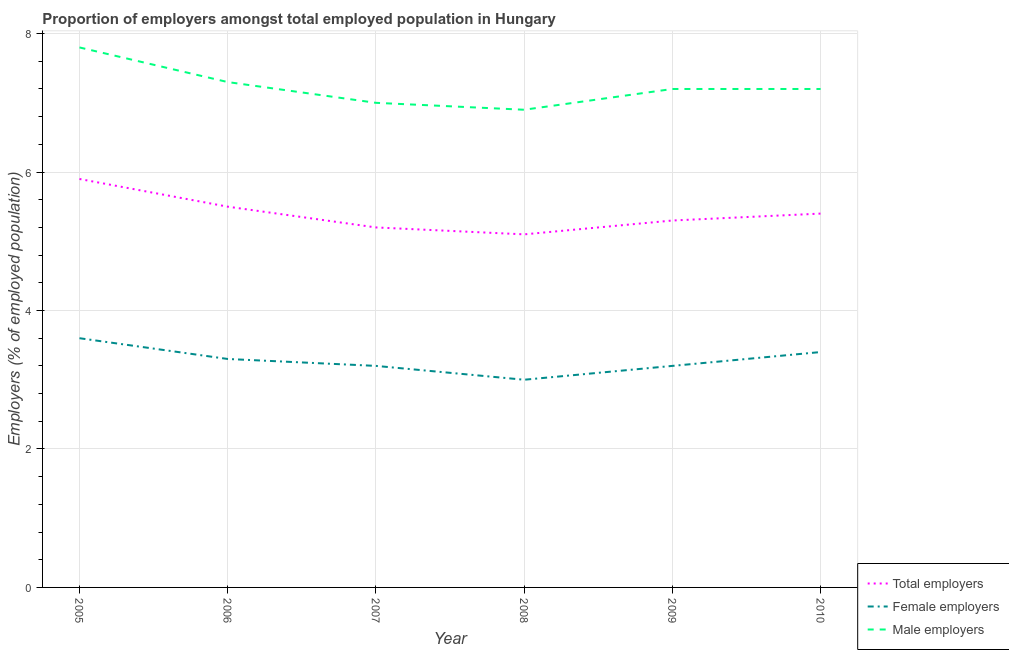Does the line corresponding to percentage of female employers intersect with the line corresponding to percentage of total employers?
Provide a short and direct response. No. What is the percentage of male employers in 2010?
Offer a very short reply. 7.2. Across all years, what is the maximum percentage of total employers?
Give a very brief answer. 5.9. In which year was the percentage of total employers maximum?
Provide a succinct answer. 2005. What is the total percentage of female employers in the graph?
Provide a succinct answer. 19.7. What is the difference between the percentage of female employers in 2006 and that in 2009?
Give a very brief answer. 0.1. What is the difference between the percentage of male employers in 2008 and the percentage of female employers in 2006?
Give a very brief answer. 3.6. What is the average percentage of female employers per year?
Provide a short and direct response. 3.28. In the year 2007, what is the difference between the percentage of male employers and percentage of total employers?
Your answer should be compact. 1.8. In how many years, is the percentage of female employers greater than 3.2 %?
Ensure brevity in your answer.  5. What is the ratio of the percentage of female employers in 2006 to that in 2007?
Your response must be concise. 1.03. Is the percentage of total employers in 2008 less than that in 2010?
Ensure brevity in your answer.  Yes. Is the difference between the percentage of total employers in 2007 and 2008 greater than the difference between the percentage of female employers in 2007 and 2008?
Give a very brief answer. No. What is the difference between the highest and the second highest percentage of total employers?
Make the answer very short. 0.4. What is the difference between the highest and the lowest percentage of total employers?
Ensure brevity in your answer.  0.8. In how many years, is the percentage of total employers greater than the average percentage of total employers taken over all years?
Offer a very short reply. 3. Is it the case that in every year, the sum of the percentage of total employers and percentage of female employers is greater than the percentage of male employers?
Provide a succinct answer. Yes. How many years are there in the graph?
Your response must be concise. 6. Are the values on the major ticks of Y-axis written in scientific E-notation?
Provide a succinct answer. No. How many legend labels are there?
Offer a terse response. 3. How are the legend labels stacked?
Your answer should be very brief. Vertical. What is the title of the graph?
Your answer should be very brief. Proportion of employers amongst total employed population in Hungary. Does "Liquid fuel" appear as one of the legend labels in the graph?
Make the answer very short. No. What is the label or title of the X-axis?
Your answer should be compact. Year. What is the label or title of the Y-axis?
Your response must be concise. Employers (% of employed population). What is the Employers (% of employed population) in Total employers in 2005?
Offer a terse response. 5.9. What is the Employers (% of employed population) of Female employers in 2005?
Provide a short and direct response. 3.6. What is the Employers (% of employed population) of Male employers in 2005?
Provide a short and direct response. 7.8. What is the Employers (% of employed population) in Total employers in 2006?
Offer a terse response. 5.5. What is the Employers (% of employed population) in Female employers in 2006?
Your answer should be compact. 3.3. What is the Employers (% of employed population) of Male employers in 2006?
Provide a short and direct response. 7.3. What is the Employers (% of employed population) in Total employers in 2007?
Your answer should be compact. 5.2. What is the Employers (% of employed population) in Female employers in 2007?
Give a very brief answer. 3.2. What is the Employers (% of employed population) in Total employers in 2008?
Your answer should be very brief. 5.1. What is the Employers (% of employed population) of Female employers in 2008?
Offer a very short reply. 3. What is the Employers (% of employed population) in Male employers in 2008?
Your answer should be compact. 6.9. What is the Employers (% of employed population) of Total employers in 2009?
Keep it short and to the point. 5.3. What is the Employers (% of employed population) in Female employers in 2009?
Make the answer very short. 3.2. What is the Employers (% of employed population) of Male employers in 2009?
Your response must be concise. 7.2. What is the Employers (% of employed population) in Total employers in 2010?
Offer a terse response. 5.4. What is the Employers (% of employed population) of Female employers in 2010?
Your answer should be compact. 3.4. What is the Employers (% of employed population) of Male employers in 2010?
Give a very brief answer. 7.2. Across all years, what is the maximum Employers (% of employed population) in Total employers?
Your answer should be very brief. 5.9. Across all years, what is the maximum Employers (% of employed population) of Female employers?
Your answer should be very brief. 3.6. Across all years, what is the maximum Employers (% of employed population) in Male employers?
Offer a very short reply. 7.8. Across all years, what is the minimum Employers (% of employed population) of Total employers?
Your answer should be very brief. 5.1. Across all years, what is the minimum Employers (% of employed population) in Female employers?
Provide a short and direct response. 3. Across all years, what is the minimum Employers (% of employed population) of Male employers?
Your answer should be very brief. 6.9. What is the total Employers (% of employed population) of Total employers in the graph?
Offer a very short reply. 32.4. What is the total Employers (% of employed population) in Female employers in the graph?
Your answer should be very brief. 19.7. What is the total Employers (% of employed population) of Male employers in the graph?
Your answer should be very brief. 43.4. What is the difference between the Employers (% of employed population) of Female employers in 2005 and that in 2006?
Ensure brevity in your answer.  0.3. What is the difference between the Employers (% of employed population) of Male employers in 2005 and that in 2006?
Your response must be concise. 0.5. What is the difference between the Employers (% of employed population) of Total employers in 2005 and that in 2007?
Ensure brevity in your answer.  0.7. What is the difference between the Employers (% of employed population) of Male employers in 2005 and that in 2007?
Offer a terse response. 0.8. What is the difference between the Employers (% of employed population) in Female employers in 2005 and that in 2008?
Your answer should be compact. 0.6. What is the difference between the Employers (% of employed population) of Male employers in 2005 and that in 2008?
Make the answer very short. 0.9. What is the difference between the Employers (% of employed population) of Total employers in 2005 and that in 2009?
Your answer should be compact. 0.6. What is the difference between the Employers (% of employed population) in Female employers in 2005 and that in 2009?
Your response must be concise. 0.4. What is the difference between the Employers (% of employed population) in Male employers in 2005 and that in 2009?
Your answer should be compact. 0.6. What is the difference between the Employers (% of employed population) in Total employers in 2005 and that in 2010?
Offer a very short reply. 0.5. What is the difference between the Employers (% of employed population) of Female employers in 2005 and that in 2010?
Make the answer very short. 0.2. What is the difference between the Employers (% of employed population) of Total employers in 2006 and that in 2007?
Provide a succinct answer. 0.3. What is the difference between the Employers (% of employed population) in Male employers in 2006 and that in 2007?
Ensure brevity in your answer.  0.3. What is the difference between the Employers (% of employed population) of Total employers in 2006 and that in 2008?
Ensure brevity in your answer.  0.4. What is the difference between the Employers (% of employed population) of Male employers in 2006 and that in 2008?
Make the answer very short. 0.4. What is the difference between the Employers (% of employed population) of Total employers in 2006 and that in 2009?
Keep it short and to the point. 0.2. What is the difference between the Employers (% of employed population) of Female employers in 2006 and that in 2009?
Your response must be concise. 0.1. What is the difference between the Employers (% of employed population) in Male employers in 2006 and that in 2009?
Provide a short and direct response. 0.1. What is the difference between the Employers (% of employed population) in Total employers in 2006 and that in 2010?
Offer a very short reply. 0.1. What is the difference between the Employers (% of employed population) of Female employers in 2006 and that in 2010?
Ensure brevity in your answer.  -0.1. What is the difference between the Employers (% of employed population) in Male employers in 2006 and that in 2010?
Your response must be concise. 0.1. What is the difference between the Employers (% of employed population) in Total employers in 2007 and that in 2008?
Make the answer very short. 0.1. What is the difference between the Employers (% of employed population) of Male employers in 2007 and that in 2009?
Offer a very short reply. -0.2. What is the difference between the Employers (% of employed population) in Total employers in 2008 and that in 2009?
Provide a succinct answer. -0.2. What is the difference between the Employers (% of employed population) in Total employers in 2008 and that in 2010?
Give a very brief answer. -0.3. What is the difference between the Employers (% of employed population) in Female employers in 2008 and that in 2010?
Ensure brevity in your answer.  -0.4. What is the difference between the Employers (% of employed population) in Female employers in 2009 and that in 2010?
Give a very brief answer. -0.2. What is the difference between the Employers (% of employed population) in Male employers in 2009 and that in 2010?
Offer a very short reply. 0. What is the difference between the Employers (% of employed population) in Female employers in 2005 and the Employers (% of employed population) in Male employers in 2006?
Your response must be concise. -3.7. What is the difference between the Employers (% of employed population) of Total employers in 2005 and the Employers (% of employed population) of Female employers in 2007?
Your answer should be compact. 2.7. What is the difference between the Employers (% of employed population) in Female employers in 2005 and the Employers (% of employed population) in Male employers in 2008?
Offer a very short reply. -3.3. What is the difference between the Employers (% of employed population) of Female employers in 2005 and the Employers (% of employed population) of Male employers in 2009?
Make the answer very short. -3.6. What is the difference between the Employers (% of employed population) in Total employers in 2006 and the Employers (% of employed population) in Male employers in 2007?
Keep it short and to the point. -1.5. What is the difference between the Employers (% of employed population) in Total employers in 2006 and the Employers (% of employed population) in Male employers in 2008?
Provide a short and direct response. -1.4. What is the difference between the Employers (% of employed population) of Female employers in 2006 and the Employers (% of employed population) of Male employers in 2008?
Your answer should be very brief. -3.6. What is the difference between the Employers (% of employed population) of Total employers in 2006 and the Employers (% of employed population) of Female employers in 2009?
Offer a very short reply. 2.3. What is the difference between the Employers (% of employed population) of Total employers in 2006 and the Employers (% of employed population) of Male employers in 2009?
Provide a short and direct response. -1.7. What is the difference between the Employers (% of employed population) of Female employers in 2006 and the Employers (% of employed population) of Male employers in 2009?
Your response must be concise. -3.9. What is the difference between the Employers (% of employed population) of Total employers in 2006 and the Employers (% of employed population) of Female employers in 2010?
Ensure brevity in your answer.  2.1. What is the difference between the Employers (% of employed population) in Total employers in 2007 and the Employers (% of employed population) in Male employers in 2008?
Offer a very short reply. -1.7. What is the difference between the Employers (% of employed population) in Total employers in 2007 and the Employers (% of employed population) in Female employers in 2009?
Provide a short and direct response. 2. What is the difference between the Employers (% of employed population) of Female employers in 2007 and the Employers (% of employed population) of Male employers in 2010?
Give a very brief answer. -4. What is the difference between the Employers (% of employed population) of Total employers in 2008 and the Employers (% of employed population) of Male employers in 2009?
Your answer should be very brief. -2.1. What is the difference between the Employers (% of employed population) in Total employers in 2008 and the Employers (% of employed population) in Female employers in 2010?
Give a very brief answer. 1.7. What is the difference between the Employers (% of employed population) of Total employers in 2009 and the Employers (% of employed population) of Female employers in 2010?
Your answer should be very brief. 1.9. What is the average Employers (% of employed population) of Total employers per year?
Keep it short and to the point. 5.4. What is the average Employers (% of employed population) of Female employers per year?
Offer a terse response. 3.28. What is the average Employers (% of employed population) in Male employers per year?
Your answer should be compact. 7.23. In the year 2005, what is the difference between the Employers (% of employed population) in Total employers and Employers (% of employed population) in Female employers?
Make the answer very short. 2.3. In the year 2005, what is the difference between the Employers (% of employed population) of Total employers and Employers (% of employed population) of Male employers?
Give a very brief answer. -1.9. In the year 2006, what is the difference between the Employers (% of employed population) in Total employers and Employers (% of employed population) in Female employers?
Provide a short and direct response. 2.2. In the year 2006, what is the difference between the Employers (% of employed population) in Total employers and Employers (% of employed population) in Male employers?
Your answer should be very brief. -1.8. In the year 2007, what is the difference between the Employers (% of employed population) of Total employers and Employers (% of employed population) of Female employers?
Make the answer very short. 2. In the year 2007, what is the difference between the Employers (% of employed population) of Female employers and Employers (% of employed population) of Male employers?
Your answer should be compact. -3.8. In the year 2008, what is the difference between the Employers (% of employed population) in Total employers and Employers (% of employed population) in Female employers?
Give a very brief answer. 2.1. In the year 2008, what is the difference between the Employers (% of employed population) of Female employers and Employers (% of employed population) of Male employers?
Your answer should be compact. -3.9. In the year 2010, what is the difference between the Employers (% of employed population) in Total employers and Employers (% of employed population) in Female employers?
Provide a short and direct response. 2. In the year 2010, what is the difference between the Employers (% of employed population) of Total employers and Employers (% of employed population) of Male employers?
Give a very brief answer. -1.8. What is the ratio of the Employers (% of employed population) of Total employers in 2005 to that in 2006?
Your answer should be very brief. 1.07. What is the ratio of the Employers (% of employed population) in Male employers in 2005 to that in 2006?
Your answer should be very brief. 1.07. What is the ratio of the Employers (% of employed population) of Total employers in 2005 to that in 2007?
Your answer should be compact. 1.13. What is the ratio of the Employers (% of employed population) in Male employers in 2005 to that in 2007?
Your response must be concise. 1.11. What is the ratio of the Employers (% of employed population) of Total employers in 2005 to that in 2008?
Your response must be concise. 1.16. What is the ratio of the Employers (% of employed population) in Female employers in 2005 to that in 2008?
Keep it short and to the point. 1.2. What is the ratio of the Employers (% of employed population) in Male employers in 2005 to that in 2008?
Ensure brevity in your answer.  1.13. What is the ratio of the Employers (% of employed population) of Total employers in 2005 to that in 2009?
Keep it short and to the point. 1.11. What is the ratio of the Employers (% of employed population) in Total employers in 2005 to that in 2010?
Offer a terse response. 1.09. What is the ratio of the Employers (% of employed population) in Female employers in 2005 to that in 2010?
Ensure brevity in your answer.  1.06. What is the ratio of the Employers (% of employed population) of Total employers in 2006 to that in 2007?
Provide a succinct answer. 1.06. What is the ratio of the Employers (% of employed population) of Female employers in 2006 to that in 2007?
Make the answer very short. 1.03. What is the ratio of the Employers (% of employed population) in Male employers in 2006 to that in 2007?
Give a very brief answer. 1.04. What is the ratio of the Employers (% of employed population) in Total employers in 2006 to that in 2008?
Keep it short and to the point. 1.08. What is the ratio of the Employers (% of employed population) of Male employers in 2006 to that in 2008?
Your response must be concise. 1.06. What is the ratio of the Employers (% of employed population) of Total employers in 2006 to that in 2009?
Give a very brief answer. 1.04. What is the ratio of the Employers (% of employed population) in Female employers in 2006 to that in 2009?
Your answer should be compact. 1.03. What is the ratio of the Employers (% of employed population) in Male employers in 2006 to that in 2009?
Provide a succinct answer. 1.01. What is the ratio of the Employers (% of employed population) of Total employers in 2006 to that in 2010?
Give a very brief answer. 1.02. What is the ratio of the Employers (% of employed population) in Female employers in 2006 to that in 2010?
Ensure brevity in your answer.  0.97. What is the ratio of the Employers (% of employed population) of Male employers in 2006 to that in 2010?
Your answer should be very brief. 1.01. What is the ratio of the Employers (% of employed population) of Total employers in 2007 to that in 2008?
Your answer should be very brief. 1.02. What is the ratio of the Employers (% of employed population) of Female employers in 2007 to that in 2008?
Provide a short and direct response. 1.07. What is the ratio of the Employers (% of employed population) in Male employers in 2007 to that in 2008?
Provide a short and direct response. 1.01. What is the ratio of the Employers (% of employed population) in Total employers in 2007 to that in 2009?
Your answer should be compact. 0.98. What is the ratio of the Employers (% of employed population) of Male employers in 2007 to that in 2009?
Give a very brief answer. 0.97. What is the ratio of the Employers (% of employed population) in Total employers in 2007 to that in 2010?
Provide a succinct answer. 0.96. What is the ratio of the Employers (% of employed population) in Male employers in 2007 to that in 2010?
Provide a short and direct response. 0.97. What is the ratio of the Employers (% of employed population) of Total employers in 2008 to that in 2009?
Your response must be concise. 0.96. What is the ratio of the Employers (% of employed population) of Female employers in 2008 to that in 2009?
Make the answer very short. 0.94. What is the ratio of the Employers (% of employed population) in Male employers in 2008 to that in 2009?
Your answer should be compact. 0.96. What is the ratio of the Employers (% of employed population) of Total employers in 2008 to that in 2010?
Offer a terse response. 0.94. What is the ratio of the Employers (% of employed population) in Female employers in 2008 to that in 2010?
Provide a succinct answer. 0.88. What is the ratio of the Employers (% of employed population) in Male employers in 2008 to that in 2010?
Your answer should be very brief. 0.96. What is the ratio of the Employers (% of employed population) in Total employers in 2009 to that in 2010?
Offer a terse response. 0.98. What is the ratio of the Employers (% of employed population) in Female employers in 2009 to that in 2010?
Give a very brief answer. 0.94. What is the ratio of the Employers (% of employed population) in Male employers in 2009 to that in 2010?
Provide a succinct answer. 1. What is the difference between the highest and the second highest Employers (% of employed population) of Female employers?
Offer a terse response. 0.2. What is the difference between the highest and the second highest Employers (% of employed population) in Male employers?
Keep it short and to the point. 0.5. What is the difference between the highest and the lowest Employers (% of employed population) of Total employers?
Ensure brevity in your answer.  0.8. 